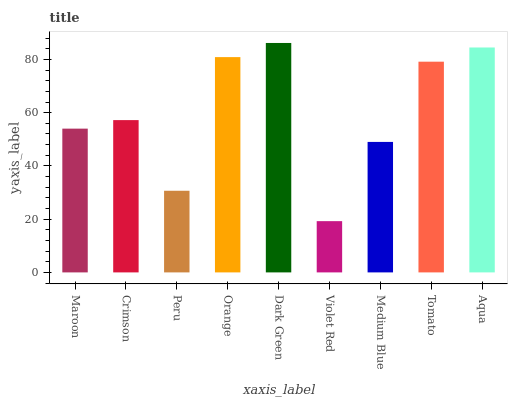Is Violet Red the minimum?
Answer yes or no. Yes. Is Dark Green the maximum?
Answer yes or no. Yes. Is Crimson the minimum?
Answer yes or no. No. Is Crimson the maximum?
Answer yes or no. No. Is Crimson greater than Maroon?
Answer yes or no. Yes. Is Maroon less than Crimson?
Answer yes or no. Yes. Is Maroon greater than Crimson?
Answer yes or no. No. Is Crimson less than Maroon?
Answer yes or no. No. Is Crimson the high median?
Answer yes or no. Yes. Is Crimson the low median?
Answer yes or no. Yes. Is Orange the high median?
Answer yes or no. No. Is Dark Green the low median?
Answer yes or no. No. 